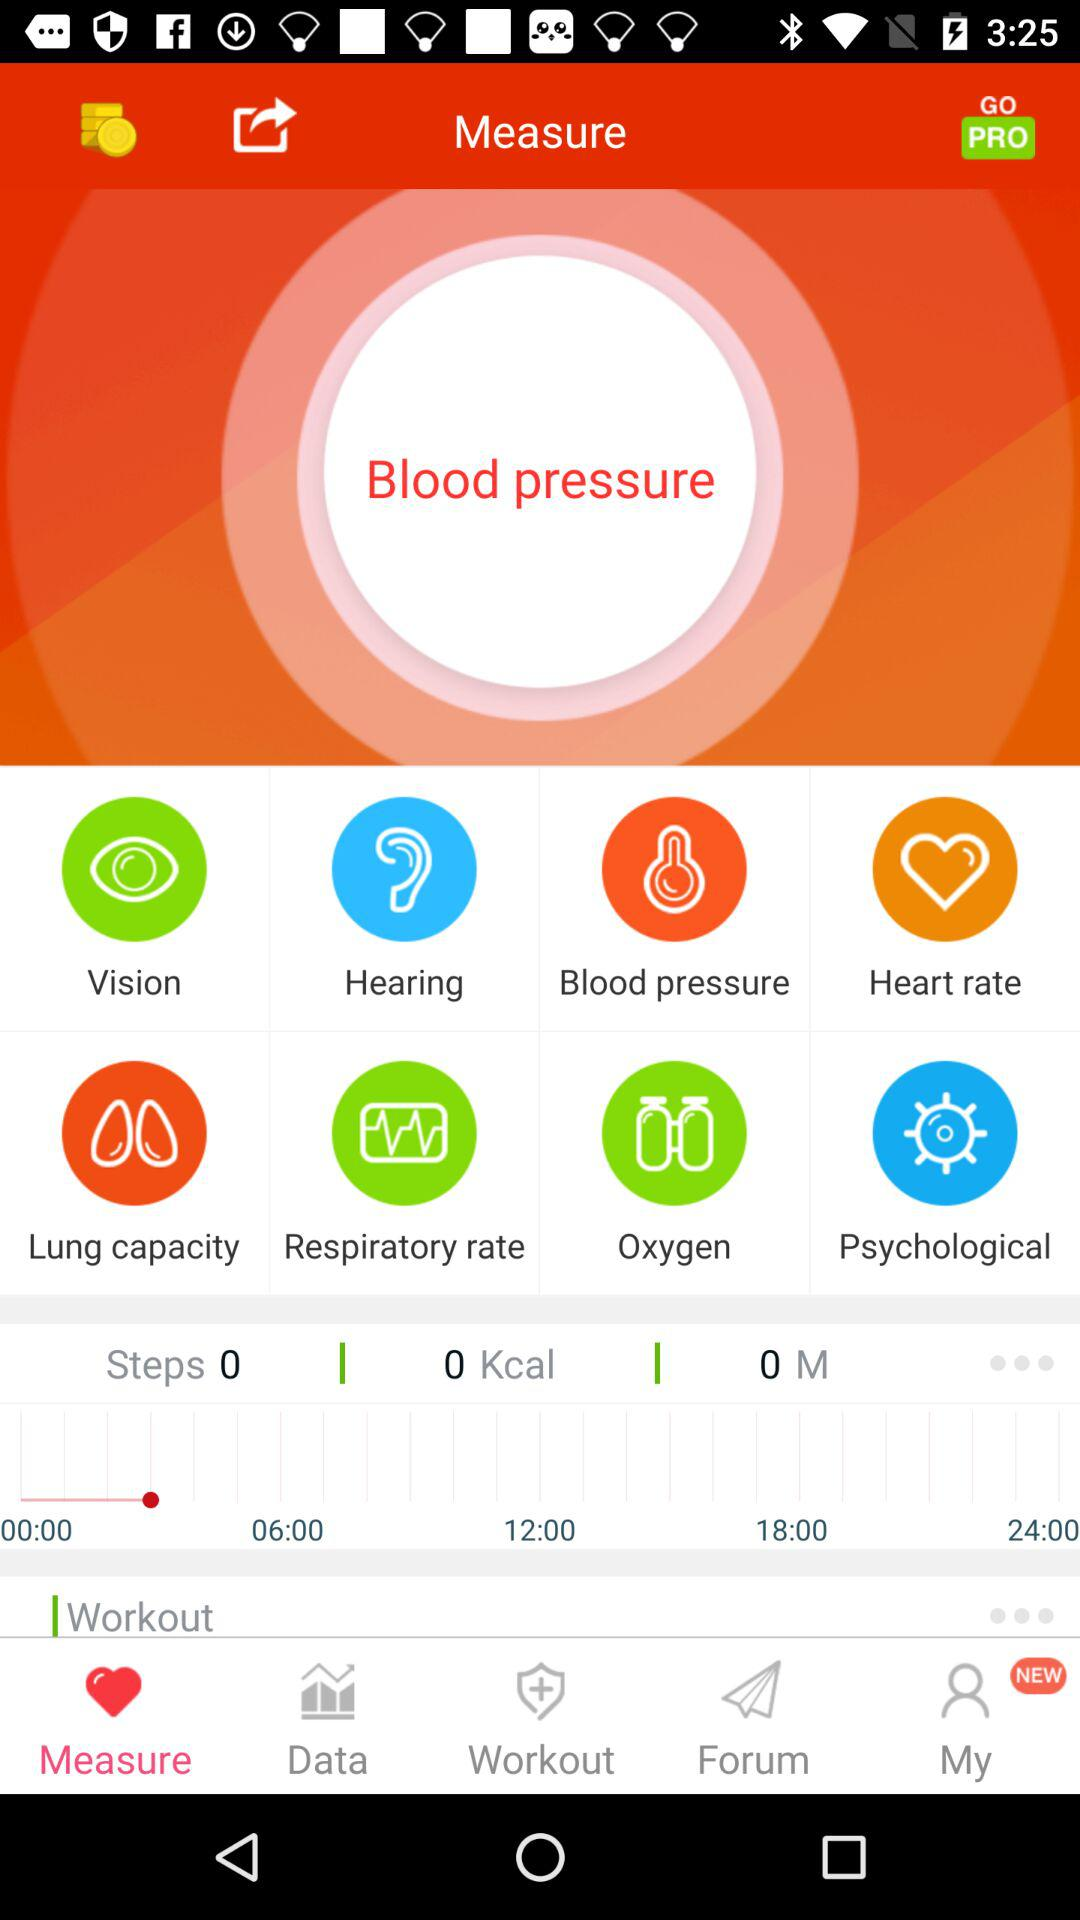What are the different health functions that can be measured? The different health functions that can be measured are "Vision", "Hearing", "Blood pressure", "Heart rate", "Lung capacity", "Respiratory rate", "Oxygen" and "Psychological". 